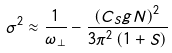Convert formula to latex. <formula><loc_0><loc_0><loc_500><loc_500>\sigma ^ { 2 } \approx \frac { 1 } { \omega _ { \perp } } - \frac { \left ( C _ { S } g N \right ) ^ { 2 } } { 3 \pi ^ { 2 } \left ( 1 + S \right ) }</formula> 